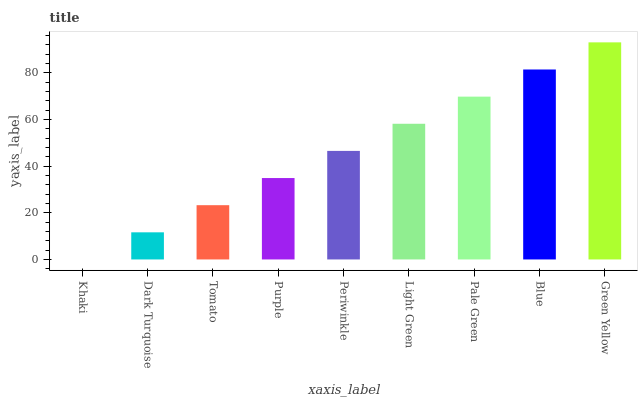Is Khaki the minimum?
Answer yes or no. Yes. Is Green Yellow the maximum?
Answer yes or no. Yes. Is Dark Turquoise the minimum?
Answer yes or no. No. Is Dark Turquoise the maximum?
Answer yes or no. No. Is Dark Turquoise greater than Khaki?
Answer yes or no. Yes. Is Khaki less than Dark Turquoise?
Answer yes or no. Yes. Is Khaki greater than Dark Turquoise?
Answer yes or no. No. Is Dark Turquoise less than Khaki?
Answer yes or no. No. Is Periwinkle the high median?
Answer yes or no. Yes. Is Periwinkle the low median?
Answer yes or no. Yes. Is Light Green the high median?
Answer yes or no. No. Is Pale Green the low median?
Answer yes or no. No. 